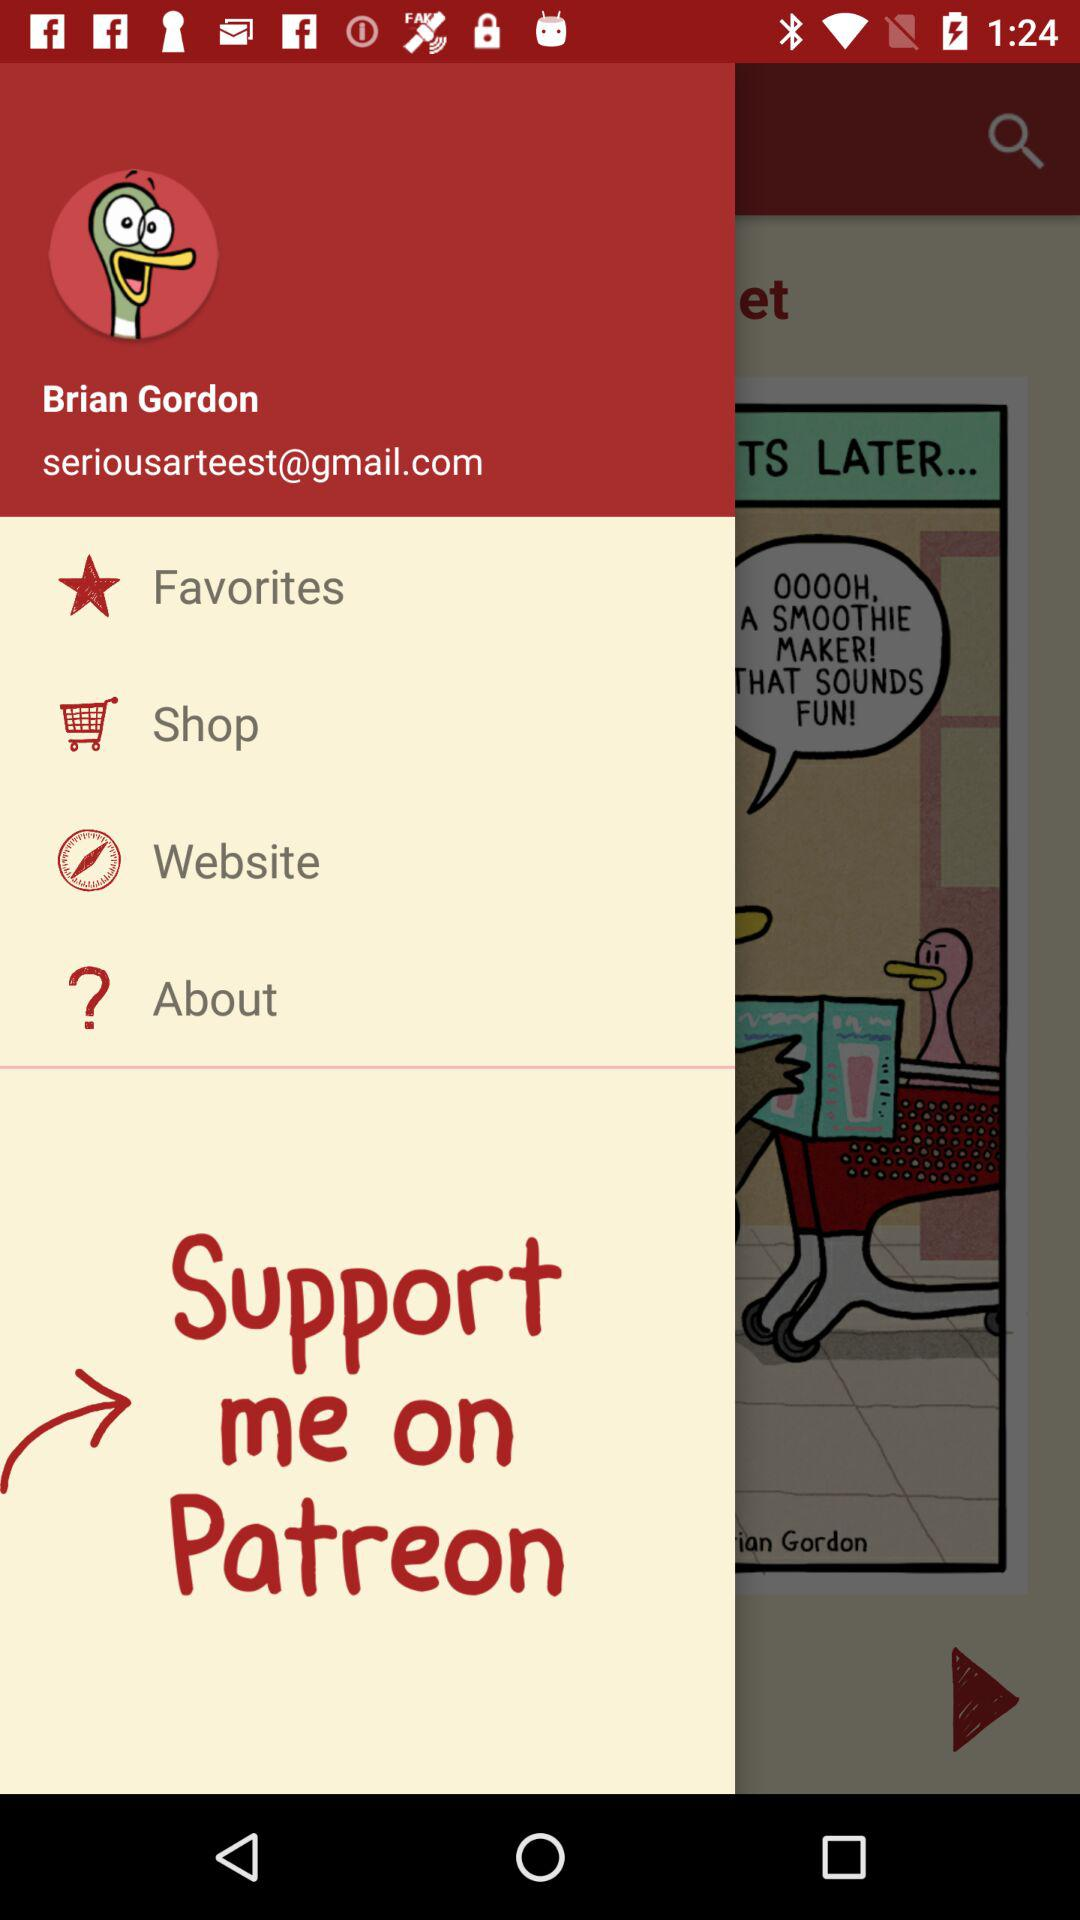What is the email address given? The email address is "seriousarteest@gmail.com". 